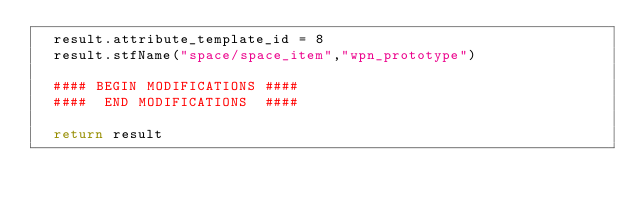Convert code to text. <code><loc_0><loc_0><loc_500><loc_500><_Python_>	result.attribute_template_id = 8
	result.stfName("space/space_item","wpn_prototype")		
	
	#### BEGIN MODIFICATIONS ####
	####  END MODIFICATIONS  ####
	
	return result</code> 